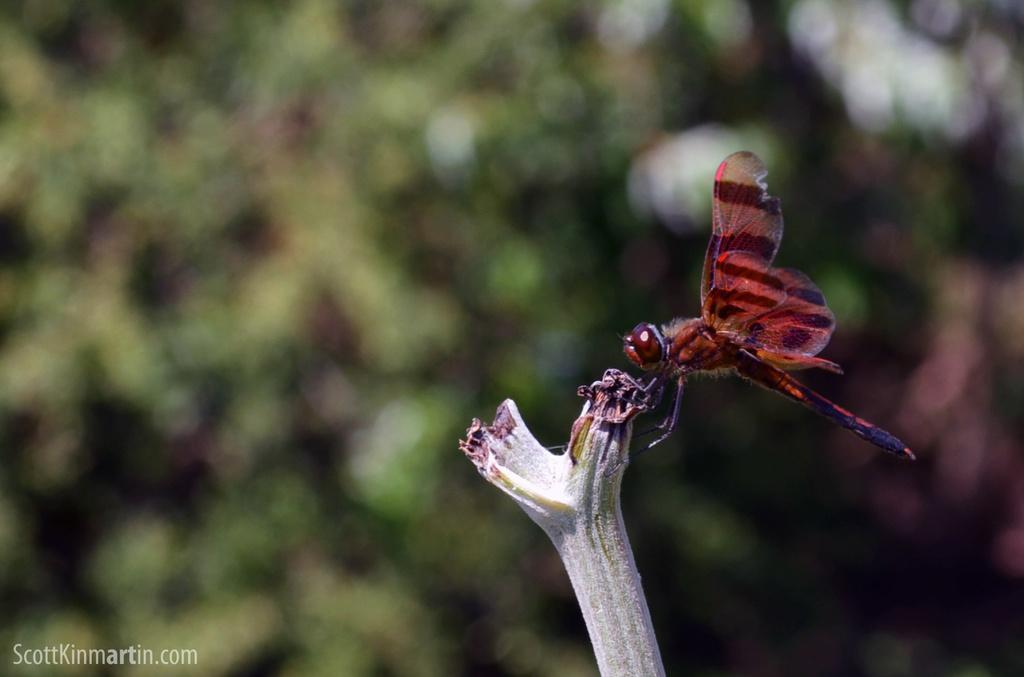How would you summarize this image in a sentence or two? There is an insect on the branch of a plant. In the bottom left, there is a watermark. And the background is blurred. 